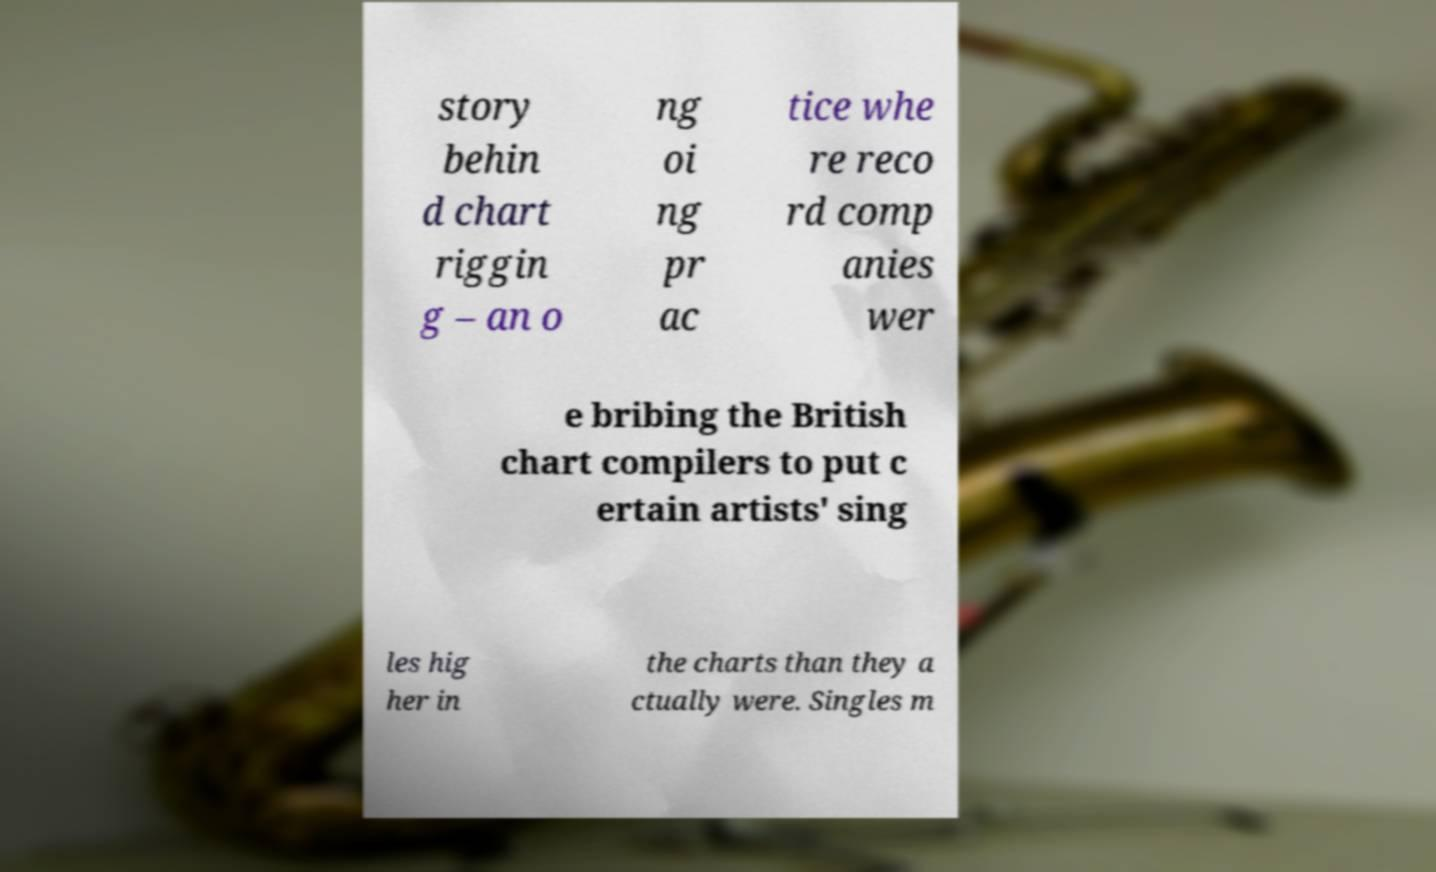What messages or text are displayed in this image? I need them in a readable, typed format. story behin d chart riggin g – an o ng oi ng pr ac tice whe re reco rd comp anies wer e bribing the British chart compilers to put c ertain artists' sing les hig her in the charts than they a ctually were. Singles m 